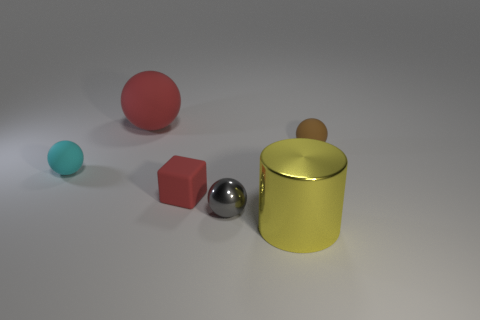There is a red thing that is behind the brown matte object; what size is it?
Keep it short and to the point. Large. How many other metallic cylinders have the same size as the yellow metallic cylinder?
Give a very brief answer. 0. What size is the block that is the same color as the big matte ball?
Offer a very short reply. Small. Is there a cylinder of the same color as the cube?
Offer a terse response. No. There is a shiny ball that is the same size as the brown matte object; what is its color?
Give a very brief answer. Gray. There is a cube; is its color the same as the metal object that is in front of the small gray shiny sphere?
Make the answer very short. No. The big metallic thing has what color?
Provide a short and direct response. Yellow. There is a object that is on the left side of the big red object; what is its material?
Your response must be concise. Rubber. What is the size of the cyan object that is the same shape as the large red rubber object?
Your response must be concise. Small. Are there fewer small cyan matte things that are in front of the cyan object than brown matte spheres?
Your answer should be very brief. Yes. 